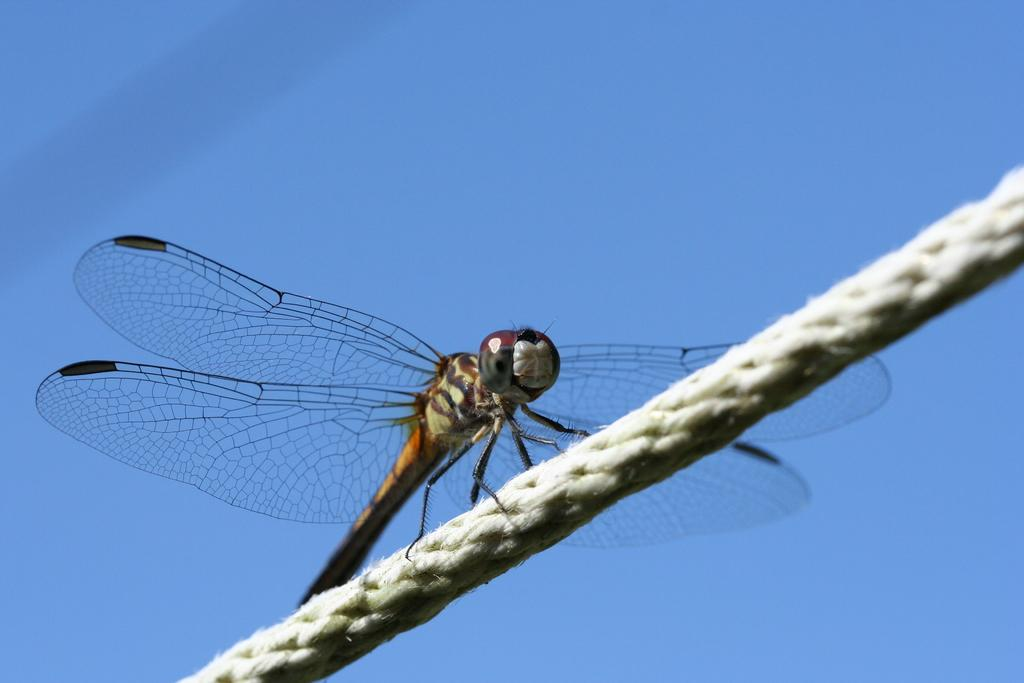What insect can be seen in the image? There is a dragonfly in the image. What is the dragonfly resting on? The dragonfly is on a rope. What can be seen in the distance in the image? There is a sky visible in the background of the image. What type of tooth is visible in the image? There is no tooth present in the image; it features a dragonfly on a rope with a sky in the background. 